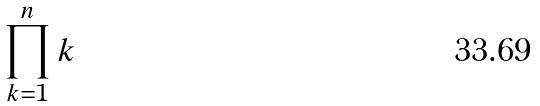<formula> <loc_0><loc_0><loc_500><loc_500>\prod _ { k = 1 } ^ { n } k</formula> 